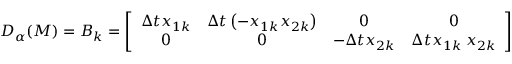Convert formula to latex. <formula><loc_0><loc_0><loc_500><loc_500>D _ { \alpha } ( M ) = B _ { k } = \left [ \begin{array} { c c c c } { \Delta t x _ { 1 k } } & { \Delta t \left ( - x _ { 1 k } x _ { 2 k } \right ) } & { 0 } & { 0 } \\ { 0 } & { 0 } & { - \Delta t x _ { 2 k } } & { \Delta t x _ { 1 k } { \, x } _ { 2 k } } \end{array} \right ]</formula> 